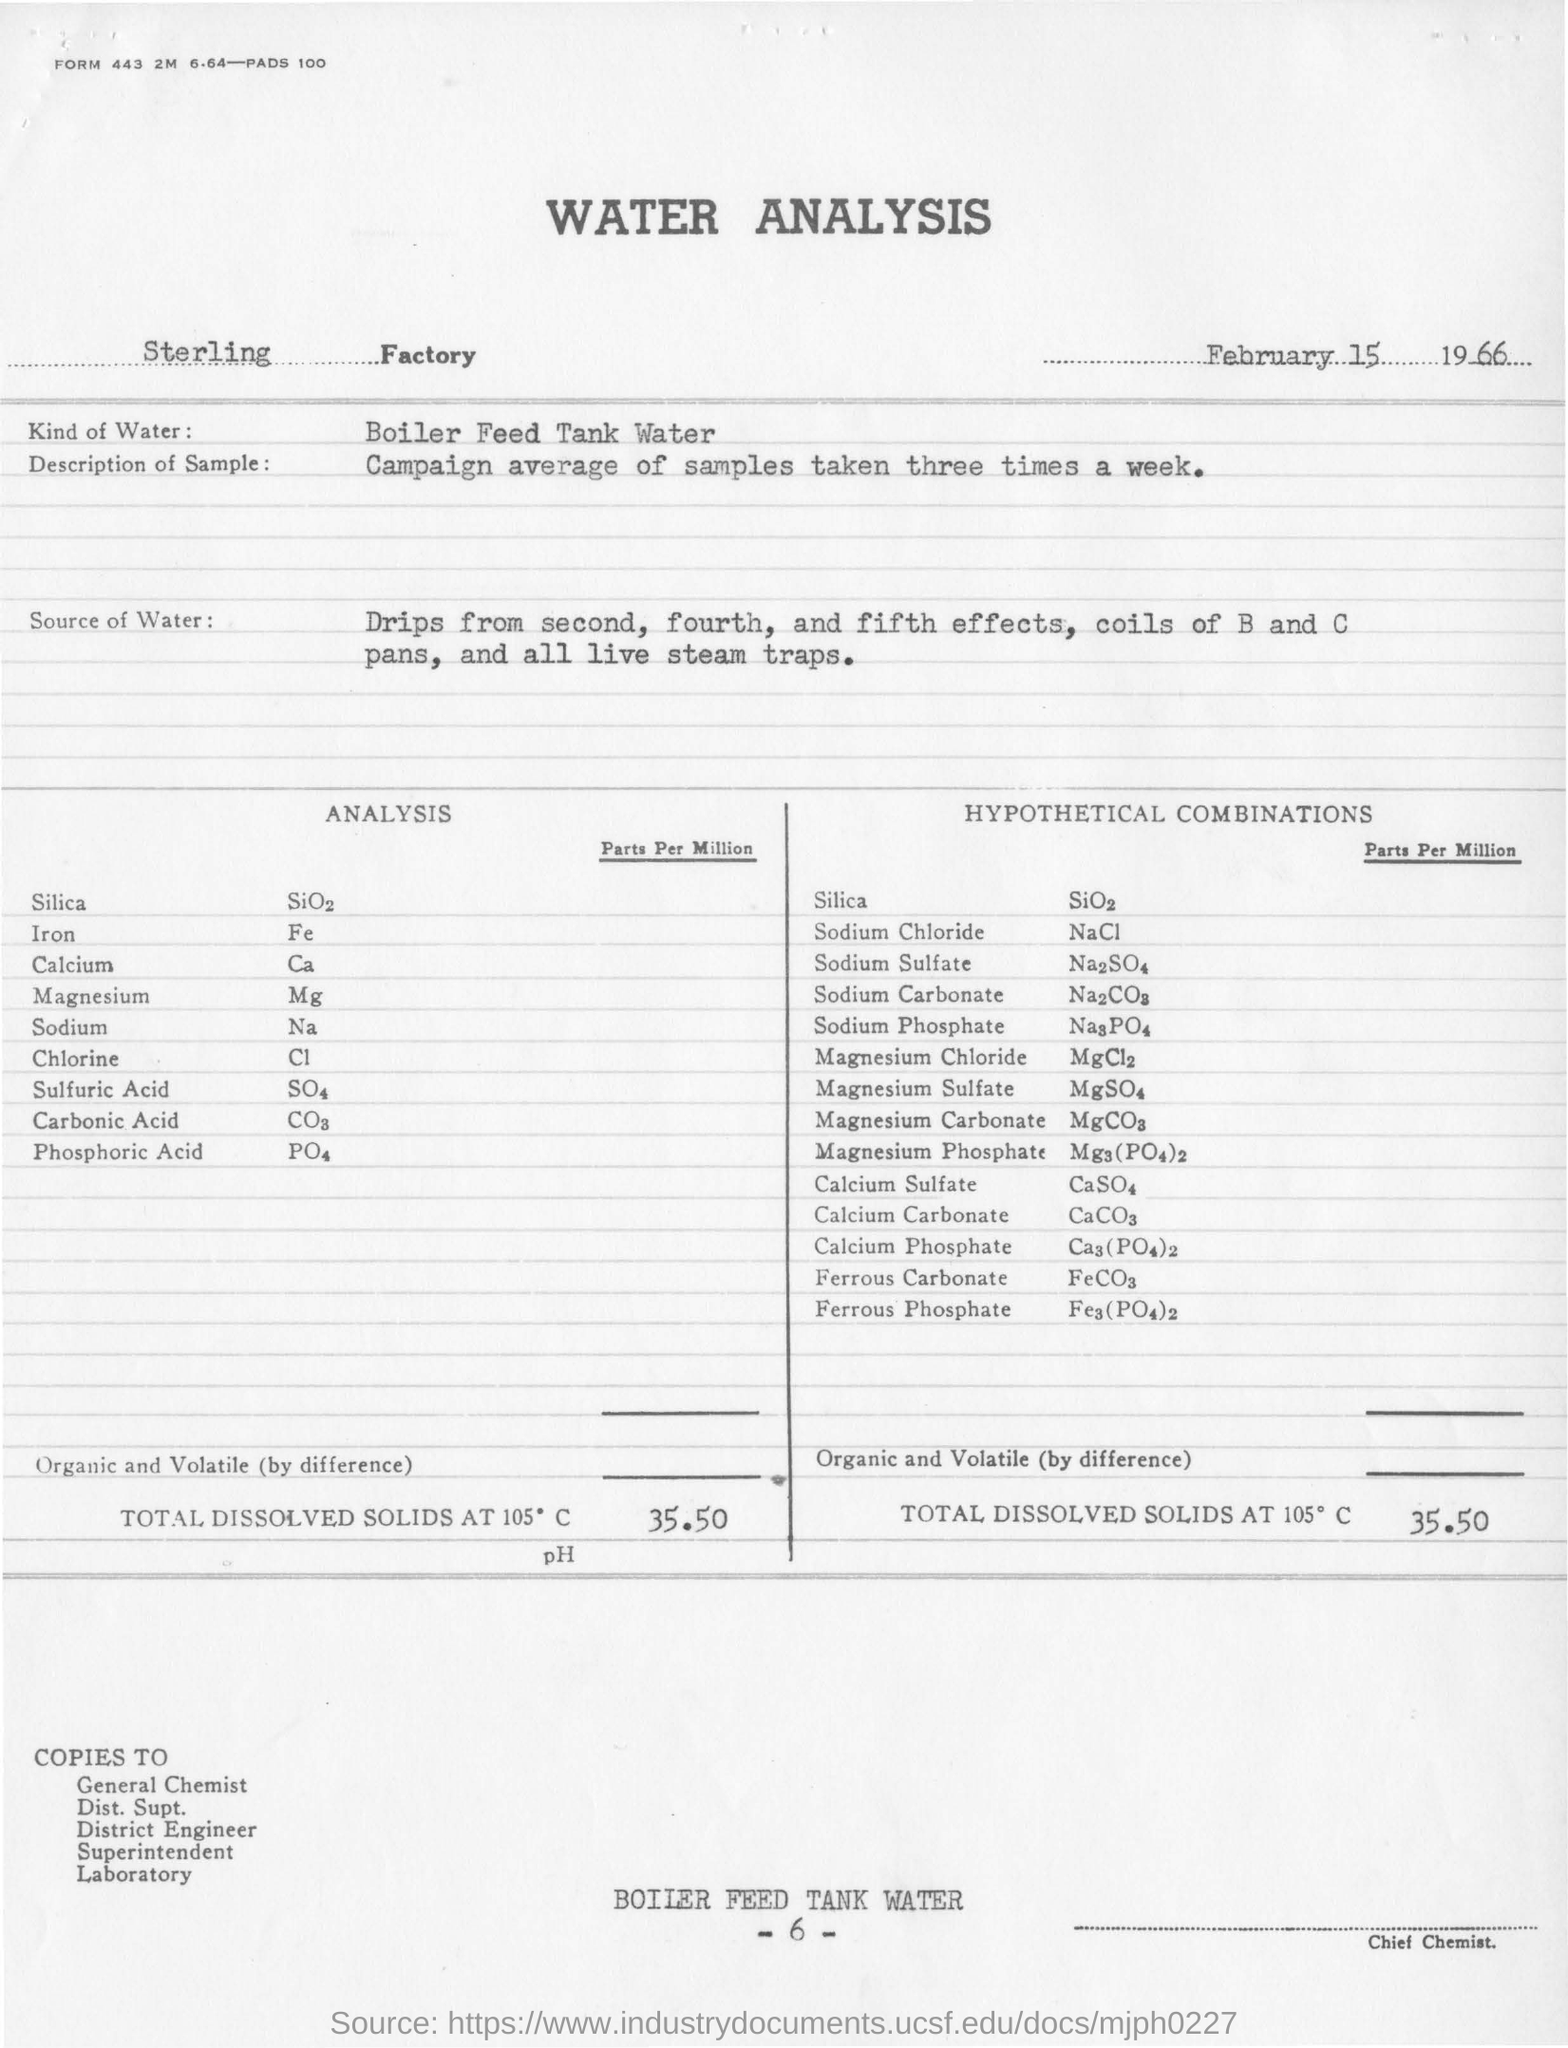List a handful of essential elements in this visual. In a typical week, three samples are taken on average as part of the "how many times in a week" campaign. The total dissolved solids at 105 degrees Celsius in the sample water for a hypothetical combination is 35.50 parts per million. The boiler feed tank water at the Sterling factory is of a particular type. The first compound listed under the title of "analysis" is silica. 